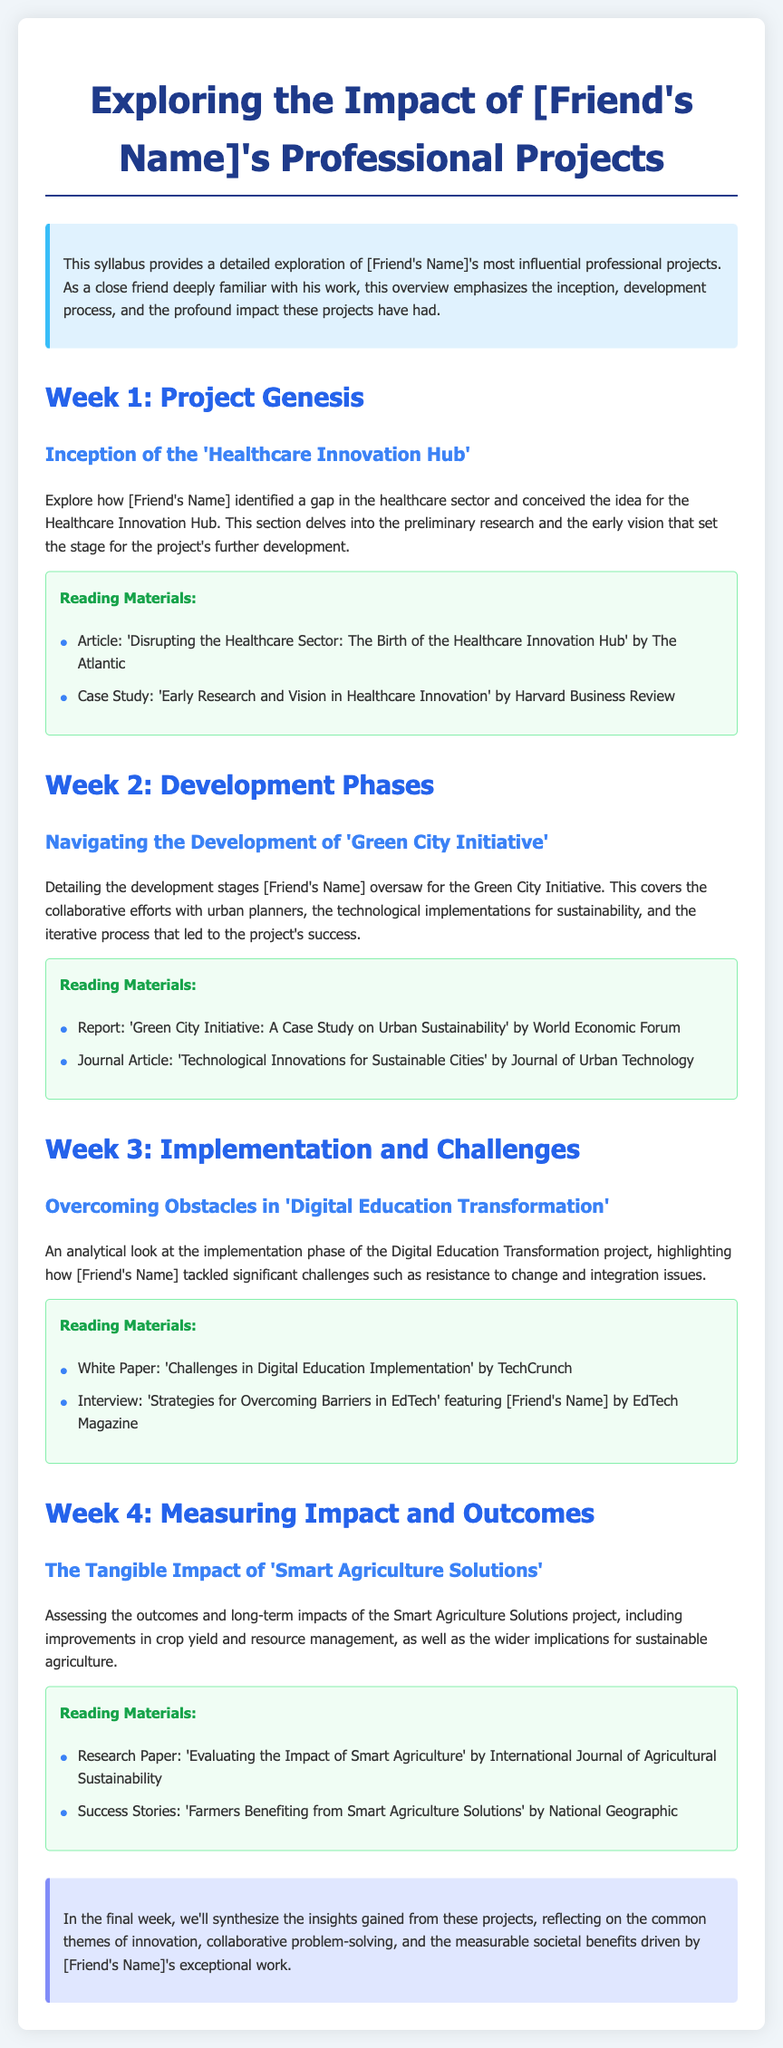What is the title of the syllabus? The title of the syllabus is clearly stated at the beginning of the document.
Answer: Exploring the Impact of [Friend's Name]'s Professional Projects What project is discussed in Week 1? The document outlines the focus of each week, with Week 1 centered on a specific project.
Answer: Healthcare Innovation Hub Which initiative is covered in Week 2? The syllabus specifies the project highlighted during the second week.
Answer: Green City Initiative What issue is addressed in the Digital Education Transformation project? The document notes a significant challenge related to a specific project in Week 3.
Answer: Resistance to change What is a reading material for Week 4? Each week includes suggested reading materials to enhance understanding; this question asks for examples from the final week.
Answer: Evaluating the Impact of Smart Agriculture Who was involved in the interview featured in Week 3? The syllabus mentions a specific person associated with a featured interview in the reading materials.
Answer: [Friend's Name] What common themes are reflected in the final week? The conclusion summarizes the overarching themes derived from the projects throughout the syllabus.
Answer: Innovation, collaborative problem-solving, societal benefits What type of papers are included in the reading materials? Each week provides different types of documents as resources; this question pertains to the types mentioned.
Answer: Articles, reports, research papers 